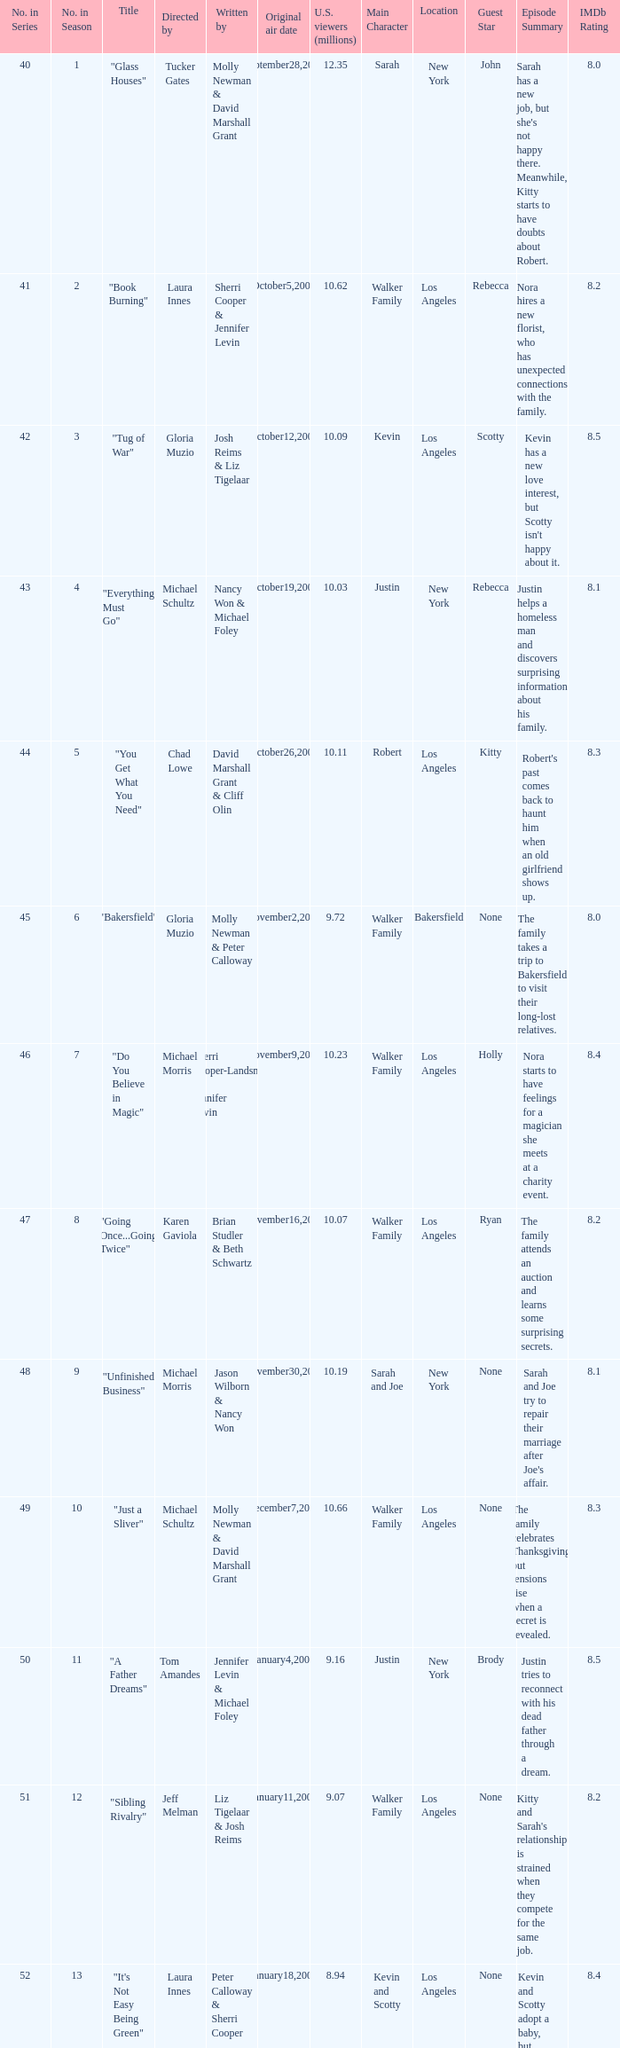Who wrote the episode whose director is Karen Gaviola? Brian Studler & Beth Schwartz. 